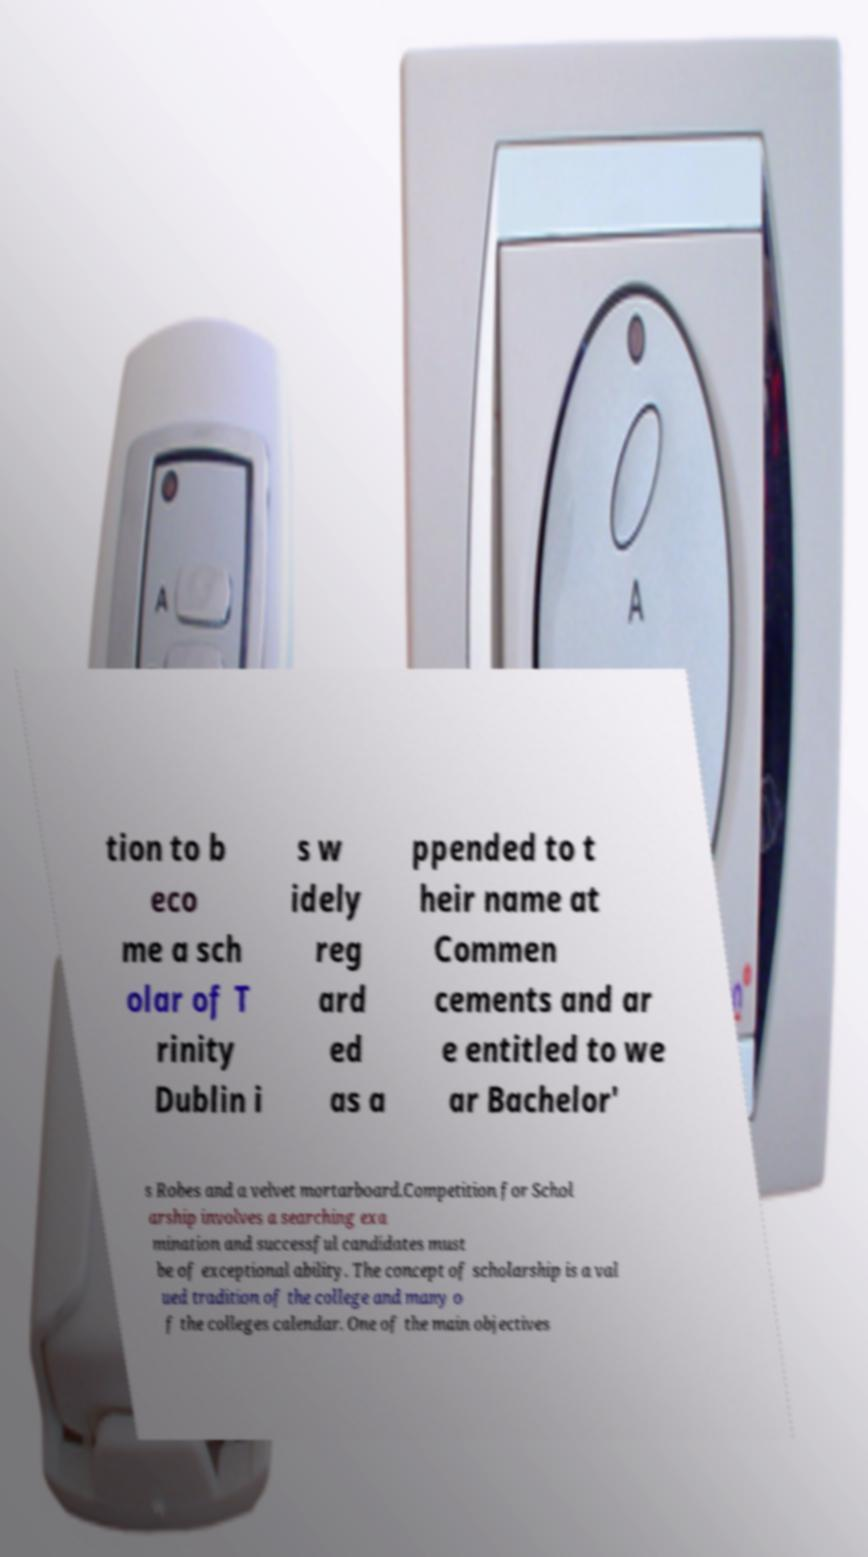Can you accurately transcribe the text from the provided image for me? tion to b eco me a sch olar of T rinity Dublin i s w idely reg ard ed as a ppended to t heir name at Commen cements and ar e entitled to we ar Bachelor' s Robes and a velvet mortarboard.Competition for Schol arship involves a searching exa mination and successful candidates must be of exceptional ability. The concept of scholarship is a val ued tradition of the college and many o f the colleges calendar. One of the main objectives 